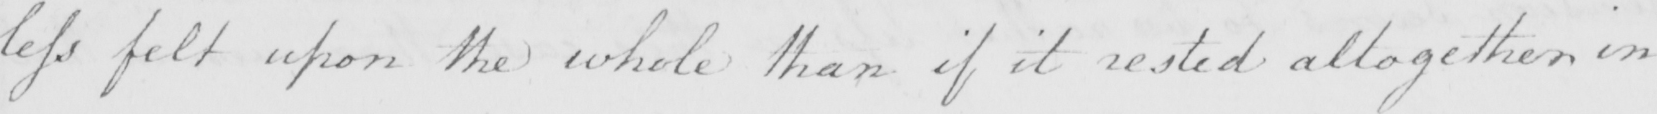Can you tell me what this handwritten text says? less felt upon the whole than if it rested altogether in 